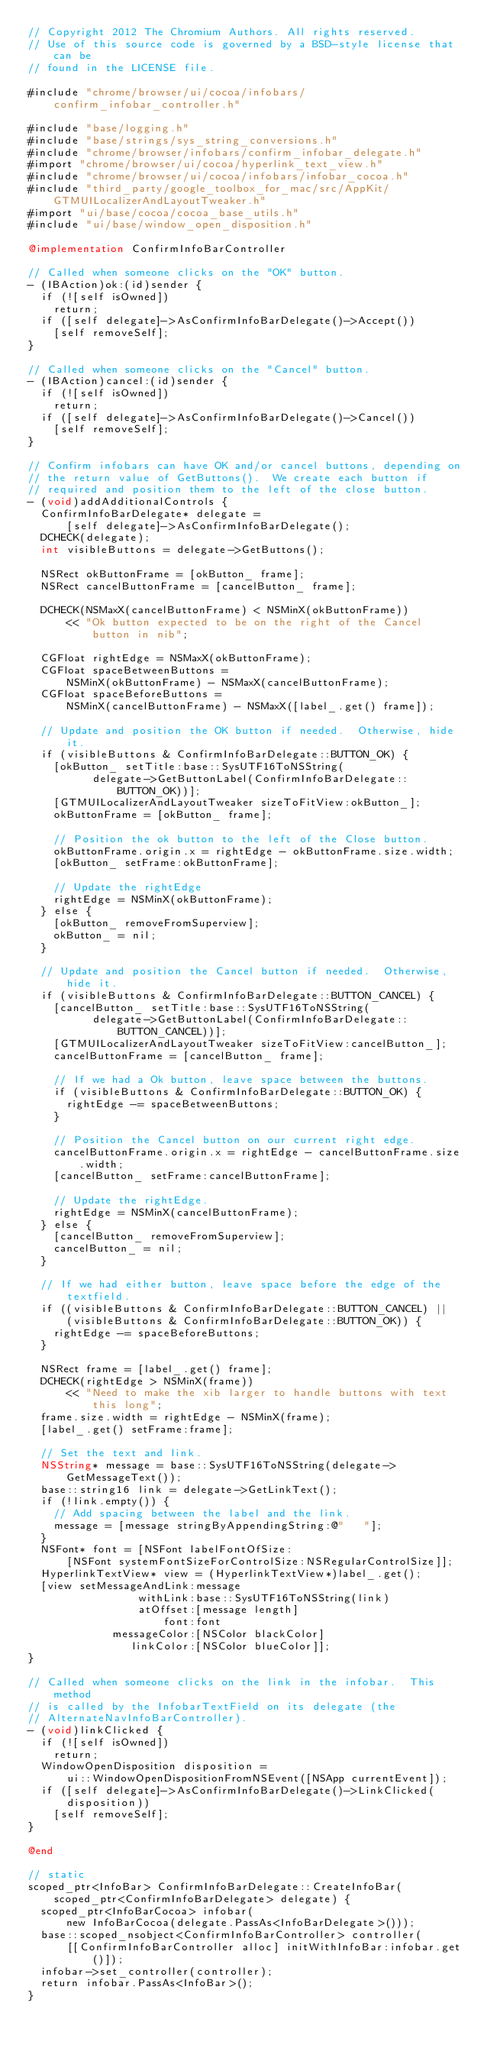Convert code to text. <code><loc_0><loc_0><loc_500><loc_500><_ObjectiveC_>// Copyright 2012 The Chromium Authors. All rights reserved.
// Use of this source code is governed by a BSD-style license that can be
// found in the LICENSE file.

#include "chrome/browser/ui/cocoa/infobars/confirm_infobar_controller.h"

#include "base/logging.h"
#include "base/strings/sys_string_conversions.h"
#include "chrome/browser/infobars/confirm_infobar_delegate.h"
#import "chrome/browser/ui/cocoa/hyperlink_text_view.h"
#include "chrome/browser/ui/cocoa/infobars/infobar_cocoa.h"
#include "third_party/google_toolbox_for_mac/src/AppKit/GTMUILocalizerAndLayoutTweaker.h"
#import "ui/base/cocoa/cocoa_base_utils.h"
#include "ui/base/window_open_disposition.h"

@implementation ConfirmInfoBarController

// Called when someone clicks on the "OK" button.
- (IBAction)ok:(id)sender {
  if (![self isOwned])
    return;
  if ([self delegate]->AsConfirmInfoBarDelegate()->Accept())
    [self removeSelf];
}

// Called when someone clicks on the "Cancel" button.
- (IBAction)cancel:(id)sender {
  if (![self isOwned])
    return;
  if ([self delegate]->AsConfirmInfoBarDelegate()->Cancel())
    [self removeSelf];
}

// Confirm infobars can have OK and/or cancel buttons, depending on
// the return value of GetButtons().  We create each button if
// required and position them to the left of the close button.
- (void)addAdditionalControls {
  ConfirmInfoBarDelegate* delegate =
      [self delegate]->AsConfirmInfoBarDelegate();
  DCHECK(delegate);
  int visibleButtons = delegate->GetButtons();

  NSRect okButtonFrame = [okButton_ frame];
  NSRect cancelButtonFrame = [cancelButton_ frame];

  DCHECK(NSMaxX(cancelButtonFrame) < NSMinX(okButtonFrame))
      << "Ok button expected to be on the right of the Cancel button in nib";

  CGFloat rightEdge = NSMaxX(okButtonFrame);
  CGFloat spaceBetweenButtons =
      NSMinX(okButtonFrame) - NSMaxX(cancelButtonFrame);
  CGFloat spaceBeforeButtons =
      NSMinX(cancelButtonFrame) - NSMaxX([label_.get() frame]);

  // Update and position the OK button if needed.  Otherwise, hide it.
  if (visibleButtons & ConfirmInfoBarDelegate::BUTTON_OK) {
    [okButton_ setTitle:base::SysUTF16ToNSString(
          delegate->GetButtonLabel(ConfirmInfoBarDelegate::BUTTON_OK))];
    [GTMUILocalizerAndLayoutTweaker sizeToFitView:okButton_];
    okButtonFrame = [okButton_ frame];

    // Position the ok button to the left of the Close button.
    okButtonFrame.origin.x = rightEdge - okButtonFrame.size.width;
    [okButton_ setFrame:okButtonFrame];

    // Update the rightEdge
    rightEdge = NSMinX(okButtonFrame);
  } else {
    [okButton_ removeFromSuperview];
    okButton_ = nil;
  }

  // Update and position the Cancel button if needed.  Otherwise, hide it.
  if (visibleButtons & ConfirmInfoBarDelegate::BUTTON_CANCEL) {
    [cancelButton_ setTitle:base::SysUTF16ToNSString(
          delegate->GetButtonLabel(ConfirmInfoBarDelegate::BUTTON_CANCEL))];
    [GTMUILocalizerAndLayoutTweaker sizeToFitView:cancelButton_];
    cancelButtonFrame = [cancelButton_ frame];

    // If we had a Ok button, leave space between the buttons.
    if (visibleButtons & ConfirmInfoBarDelegate::BUTTON_OK) {
      rightEdge -= spaceBetweenButtons;
    }

    // Position the Cancel button on our current right edge.
    cancelButtonFrame.origin.x = rightEdge - cancelButtonFrame.size.width;
    [cancelButton_ setFrame:cancelButtonFrame];

    // Update the rightEdge.
    rightEdge = NSMinX(cancelButtonFrame);
  } else {
    [cancelButton_ removeFromSuperview];
    cancelButton_ = nil;
  }

  // If we had either button, leave space before the edge of the textfield.
  if ((visibleButtons & ConfirmInfoBarDelegate::BUTTON_CANCEL) ||
      (visibleButtons & ConfirmInfoBarDelegate::BUTTON_OK)) {
    rightEdge -= spaceBeforeButtons;
  }

  NSRect frame = [label_.get() frame];
  DCHECK(rightEdge > NSMinX(frame))
      << "Need to make the xib larger to handle buttons with text this long";
  frame.size.width = rightEdge - NSMinX(frame);
  [label_.get() setFrame:frame];

  // Set the text and link.
  NSString* message = base::SysUTF16ToNSString(delegate->GetMessageText());
  base::string16 link = delegate->GetLinkText();
  if (!link.empty()) {
    // Add spacing between the label and the link.
    message = [message stringByAppendingString:@"   "];
  }
  NSFont* font = [NSFont labelFontOfSize:
      [NSFont systemFontSizeForControlSize:NSRegularControlSize]];
  HyperlinkTextView* view = (HyperlinkTextView*)label_.get();
  [view setMessageAndLink:message
                 withLink:base::SysUTF16ToNSString(link)
                 atOffset:[message length]
                     font:font
             messageColor:[NSColor blackColor]
                linkColor:[NSColor blueColor]];
}

// Called when someone clicks on the link in the infobar.  This method
// is called by the InfobarTextField on its delegate (the
// AlternateNavInfoBarController).
- (void)linkClicked {
  if (![self isOwned])
    return;
  WindowOpenDisposition disposition =
      ui::WindowOpenDispositionFromNSEvent([NSApp currentEvent]);
  if ([self delegate]->AsConfirmInfoBarDelegate()->LinkClicked(disposition))
    [self removeSelf];
}

@end

// static
scoped_ptr<InfoBar> ConfirmInfoBarDelegate::CreateInfoBar(
    scoped_ptr<ConfirmInfoBarDelegate> delegate) {
  scoped_ptr<InfoBarCocoa> infobar(
      new InfoBarCocoa(delegate.PassAs<InfoBarDelegate>()));
  base::scoped_nsobject<ConfirmInfoBarController> controller(
      [[ConfirmInfoBarController alloc] initWithInfoBar:infobar.get()]);
  infobar->set_controller(controller);
  return infobar.PassAs<InfoBar>();
}
</code> 